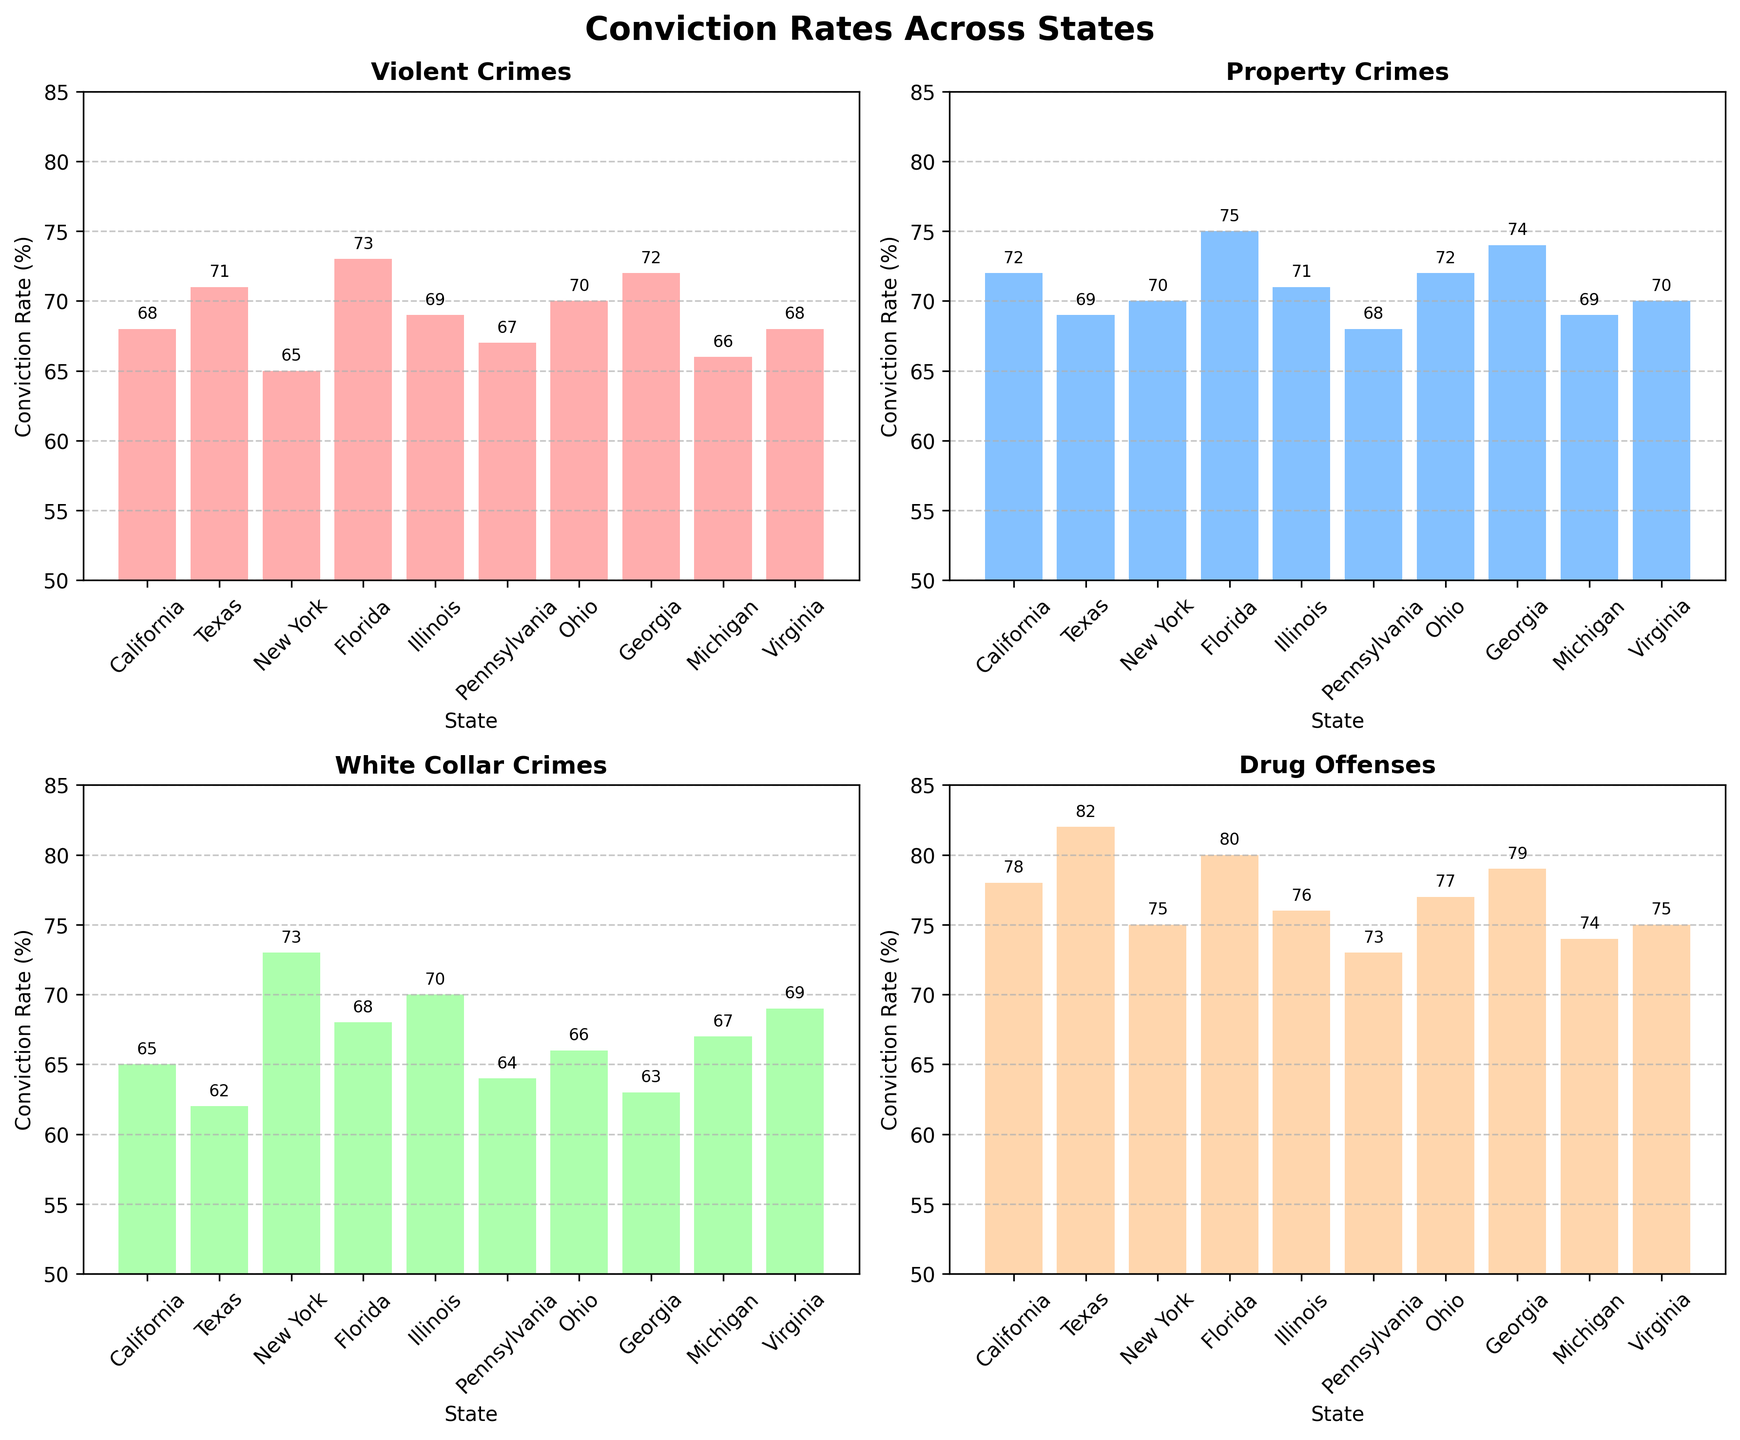Which state has the highest conviction rate for Drug Offenses? By looking at the "Drug Offenses" subplot, we observe the bar heights. The highest bar corresponds to Texas with a conviction rate of 82%.
Answer: Texas Which state has the lowest conviction rate for Violent Crimes? In the "Violent Crimes" subplot, we see that the shortest bar belongs to New York, with a conviction rate of 65%.
Answer: New York Compare the conviction rates for Property Crimes in California and Florida. Which one is higher? In the "Property Crimes" subplot, Florida has a taller bar (75%) compared to California (72%). Thus, Florida has a higher conviction rate for Property Crimes.
Answer: Florida What is the range of conviction rates for White Collar Crimes across all states? The range is found by subtracting the lowest conviction rate from the highest. New York has the highest rate (73%) and Georgia has the lowest (63%). Therefore, the range is 73 - 63 = 10.
Answer: 10 Calculate the average conviction rate for Violent Crimes across all states. Adding the conviction rates for Violent Crimes: 68 + 71 + 65 + 73 + 69 + 67 + 70 + 72 + 66 + 68 = 689. Dividing by the number of states (10) gives an average of 689 / 10 = 68.9.
Answer: 68.9 Which type of crime generally has the lowest conviction rates across the given states? By observing all subplots together, White Collar Crimes consistently have lower conviction rates compared to other crime categories.
Answer: White Collar Crimes What is the difference in conviction rates for Drug Offenses between Ohio and Pennsylvania? From the "Drug Offenses" subplot, Ohio has a rate of 77% and Pennsylvania has 73%. The difference is 77 - 73 = 4.
Answer: 4 Is there a state that has a consistent conviction rate of 70% across three different crime categories? Texas and Illinois do not qualify, as each has varying rates. However, looking closer, Illinois has consistent rates near but not exactly at 70% (Property Crimes-71%, White Collar Crimes-70%, Drug Offenses-76%). No state has exactly 70% across three categories.
Answer: No Which state shows the highest variance in conviction rates among the different crime types? To find the variance, we observe the conviction rates for each crime type in all states and notice Texas varies from 62% (White Collar Crimes) to 82% (Drug Offenses), a difference of 20%. Thus, Texas has the highest variance.
Answer: Texas Compare the total conviction rates for all types of crimes in Ohio and Georgia. Which state has a higher total? Summing Ohio's rates: 70 + 72 + 66 + 77 = 285. Summing Georgia's rates: 72 + 74 + 63 + 79 = 288. Georgia has a higher total conviction rate.
Answer: Georgia 